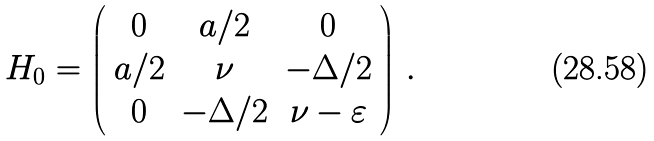<formula> <loc_0><loc_0><loc_500><loc_500>H _ { 0 } = \left ( \begin{array} { c c c } 0 & a / 2 & 0 \\ a / 2 & \nu & - \Delta / 2 \\ 0 & - \Delta / 2 & \nu - \varepsilon \end{array} \right ) \, .</formula> 